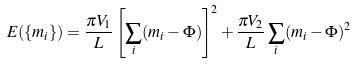<formula> <loc_0><loc_0><loc_500><loc_500>E ( \{ m _ { i } \} ) = \frac { \pi V _ { 1 } } { L } \left [ \sum _ { i } ( m _ { i } - \Phi ) \right ] ^ { 2 } + \frac { \pi V _ { 2 } } { L } \sum _ { i } ( m _ { i } - \Phi ) ^ { 2 }</formula> 